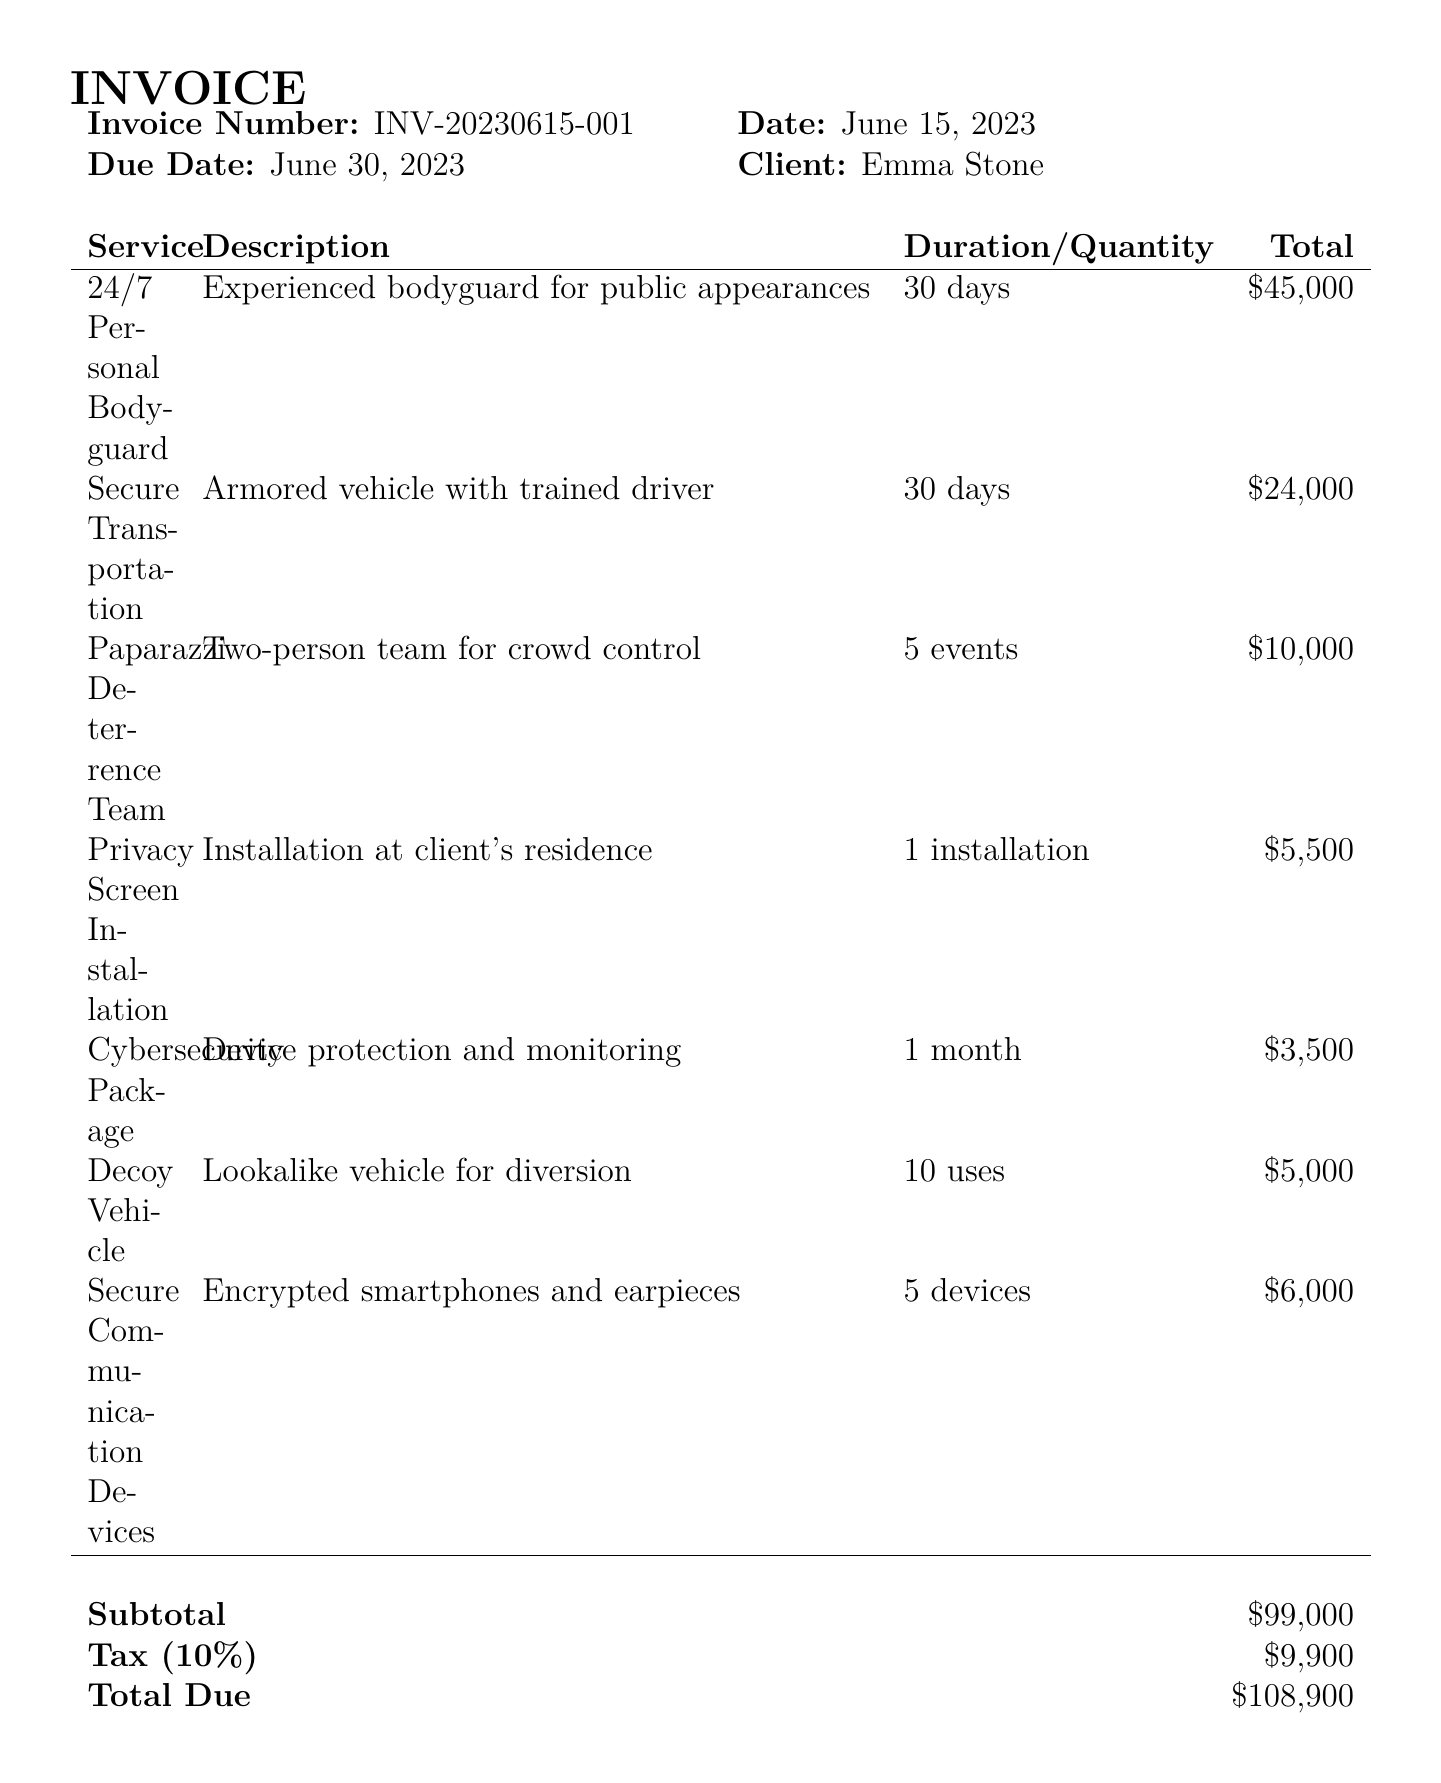What is the invoice number? The invoice number is a unique identifier for the transaction, listed at the top of the document.
Answer: INV-20230615-001 What is the total amount due? The total amount due is the final amount the client needs to pay after taxes have been added to the subtotal.
Answer: $108,900 What security service has a duration of 1 month? The security service that lasts for one month includes cybersecurity measures for the client's protection.
Answer: Cybersecurity Package How many personal bodyguard days are included in the invoice? The duration of the personal bodyguard service is specified in days and can be found in the itemized list.
Answer: 30 days What is the tax amount listed in the invoice? The tax amount is a percentage applied to the subtotal and is clearly stated in the financial breakdown.
Answer: $9,900 How many devices are included in the secure communication package? The secure communication devices section specifies the quantity provided to the client for secure communication.
Answer: 5 devices What is the cancellation policy fee? The cancellation policy outlines the percentage fee that will be charged if a cancellation occurs within a specific timeframe.
Answer: 50% What is included in the additional notes? The additional notes elaborate on guarantees and provisions provided by the security company.
Answer: All security personnel are licensed and trained in celebrity protection What payment method is specified in the document? The payment method details how the client should make the payment for the services rendered.
Answer: Wire transfer to Celebrity Shield Security Services 